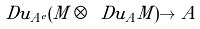Convert formula to latex. <formula><loc_0><loc_0><loc_500><loc_500>\ D u _ { A ^ { e } } ( M \otimes \ D u _ { A } M ) \to A</formula> 